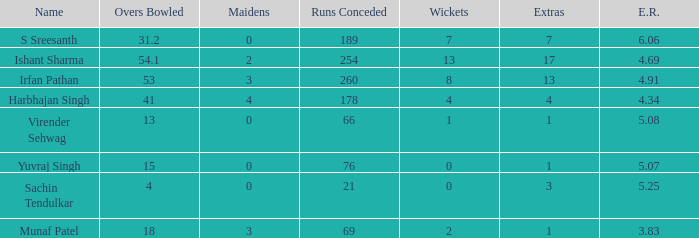List the maidens with a total of 13 overs bowled. 0.0. 